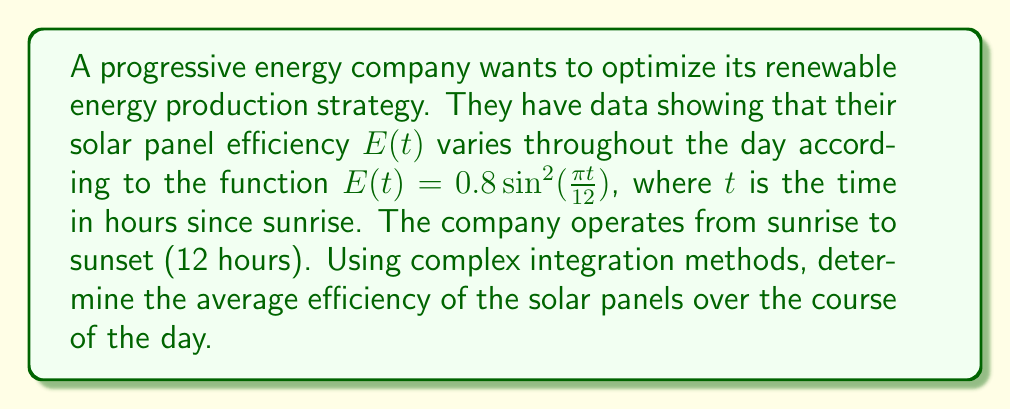Give your solution to this math problem. To solve this problem, we'll use the following steps:

1) The average efficiency is given by the integral of the efficiency function divided by the time period:

   $$\text{Average Efficiency} = \frac{1}{12} \int_0^{12} E(t) dt$$

2) Substitute the given function:

   $$\frac{1}{12} \int_0^{12} 0.8 \sin^2(\frac{\pi t}{12}) dt$$

3) To solve this using complex integration, we'll use the identity:

   $$\sin^2(x) = \frac{1 - \cos(2x)}{2}$$

4) Applying this to our integral:

   $$\frac{1}{12} \int_0^{12} 0.8 \cdot \frac{1 - \cos(\frac{\pi t}{6})}{2} dt$$

5) Simplify:

   $$\frac{0.4}{12} \int_0^{12} (1 - \cos(\frac{\pi t}{6})) dt$$

6) Evaluate the integral:

   $$\frac{0.4}{12} [t - \frac{6}{\pi} \sin(\frac{\pi t}{6})]_0^{12}$$

7) Plug in the limits:

   $$\frac{0.4}{12} [(12 - \frac{6}{\pi} \sin(2\pi)) - (0 - \frac{6}{\pi} \sin(0))]$$

8) Simplify:

   $$\frac{0.4}{12} \cdot 12 = 0.4$$

Therefore, the average efficiency over the course of the day is 0.4 or 40%.
Answer: 0.4 